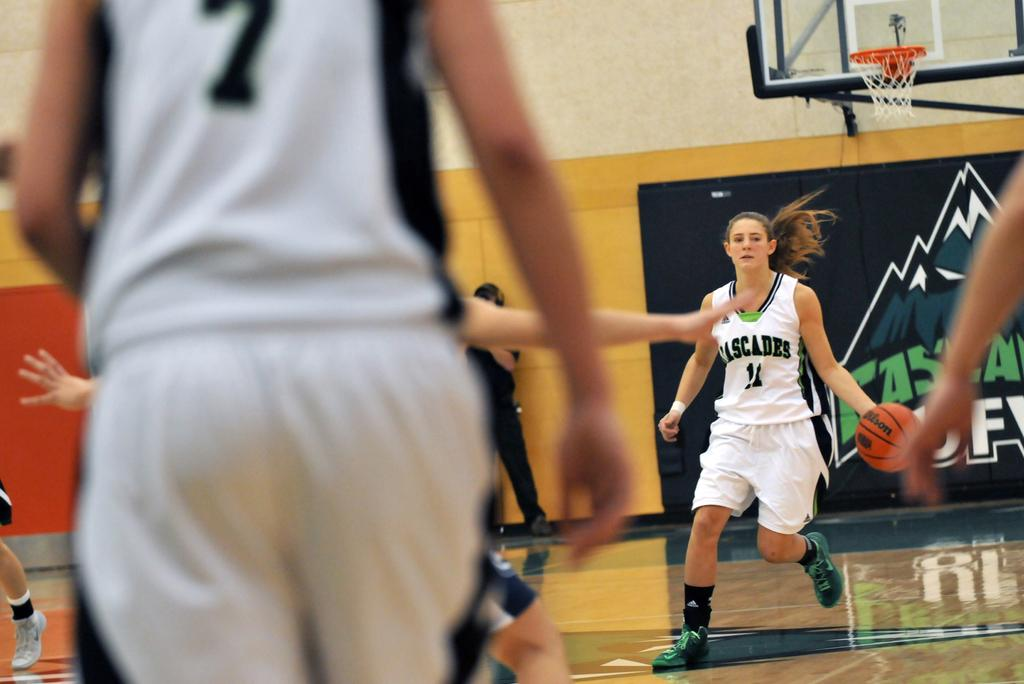Provide a one-sentence caption for the provided image. A female basketball player depicting the number 7 on the back of her jersey faces a teammate that has possession of the basketball. 